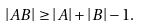Convert formula to latex. <formula><loc_0><loc_0><loc_500><loc_500>\left | A B \right | \geq \left | A \right | + \left | B \right | - 1 .</formula> 